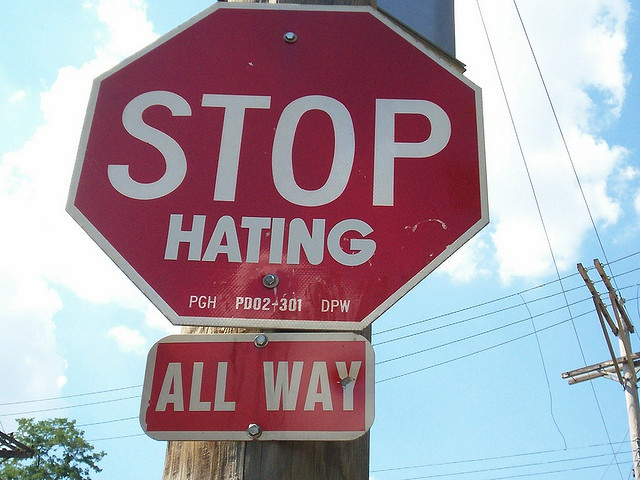Describe the objects in this image and their specific colors. I can see a stop sign in lightblue, brown, and darkgray tones in this image. 